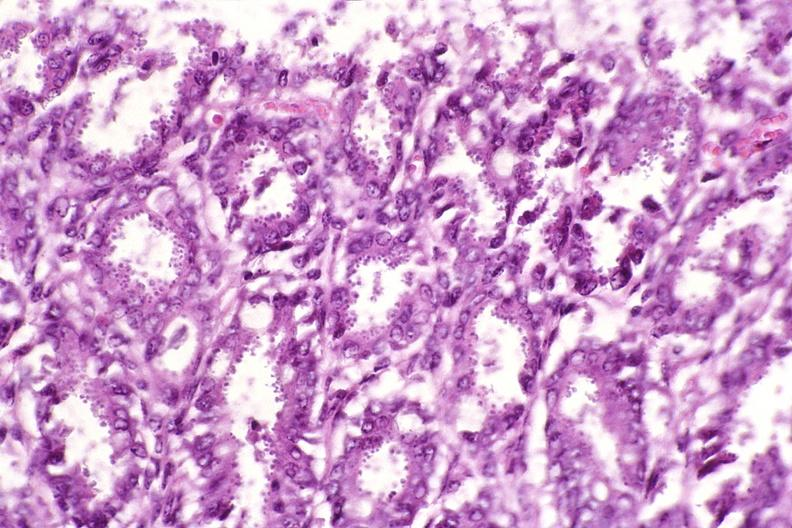where is this from?
Answer the question using a single word or phrase. Gastrointestinal system 